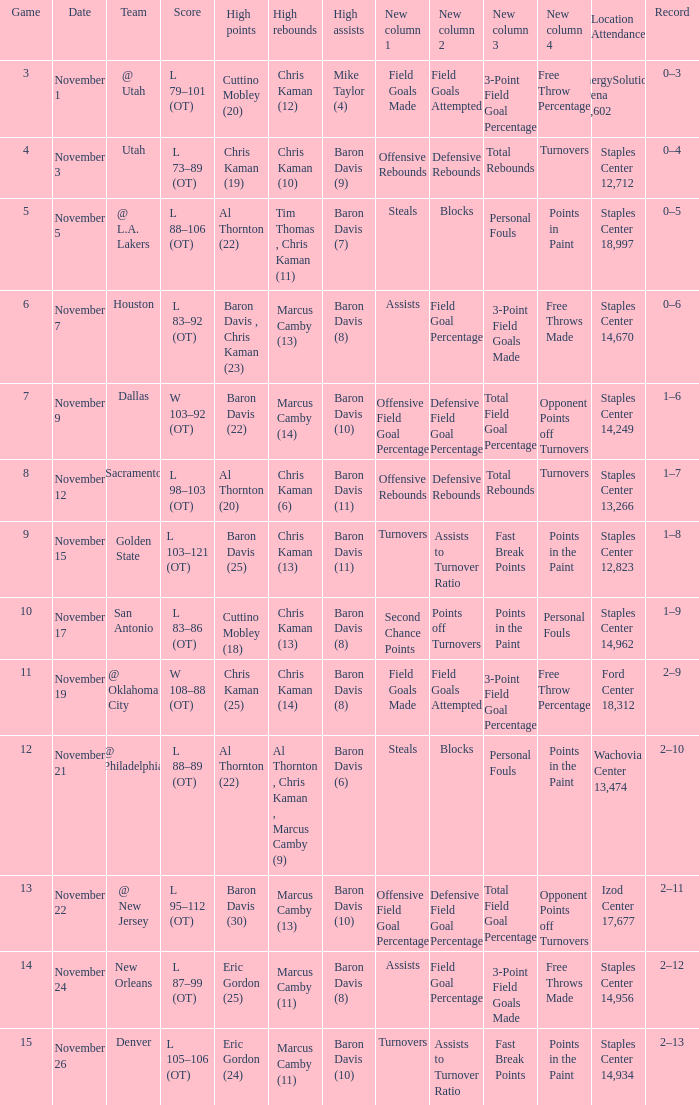Name the high points for the date of november 24 Eric Gordon (25). 